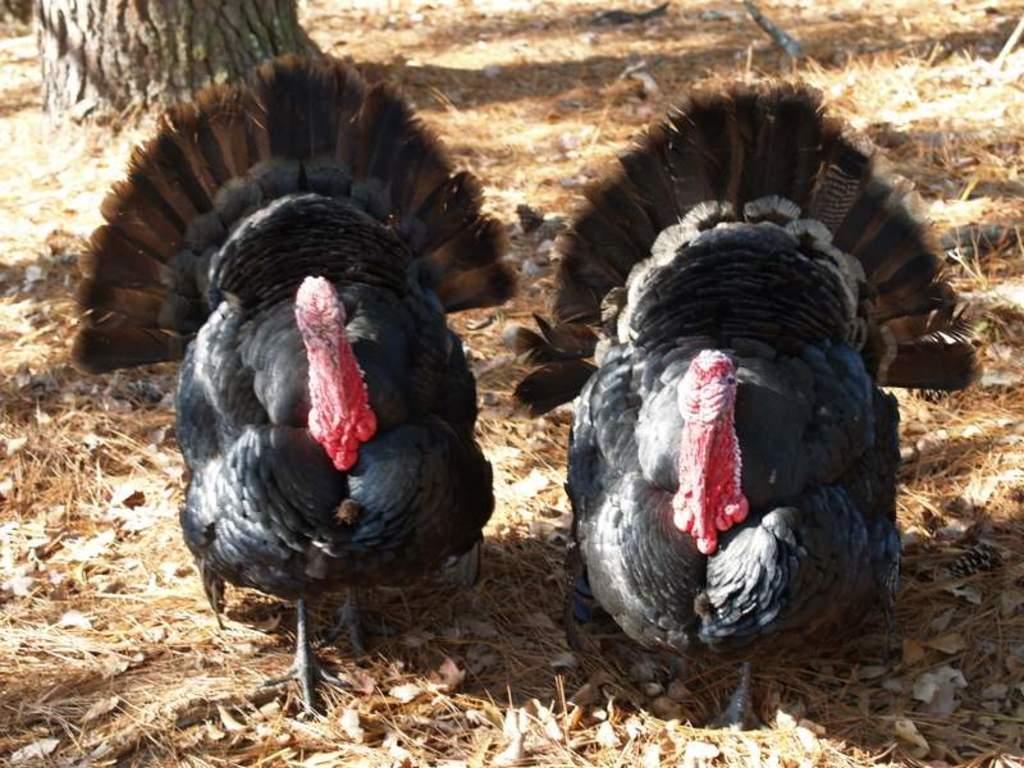Can you describe this image briefly? In this image I can see two birds in black and red color and I can see dried grass in brown color. 